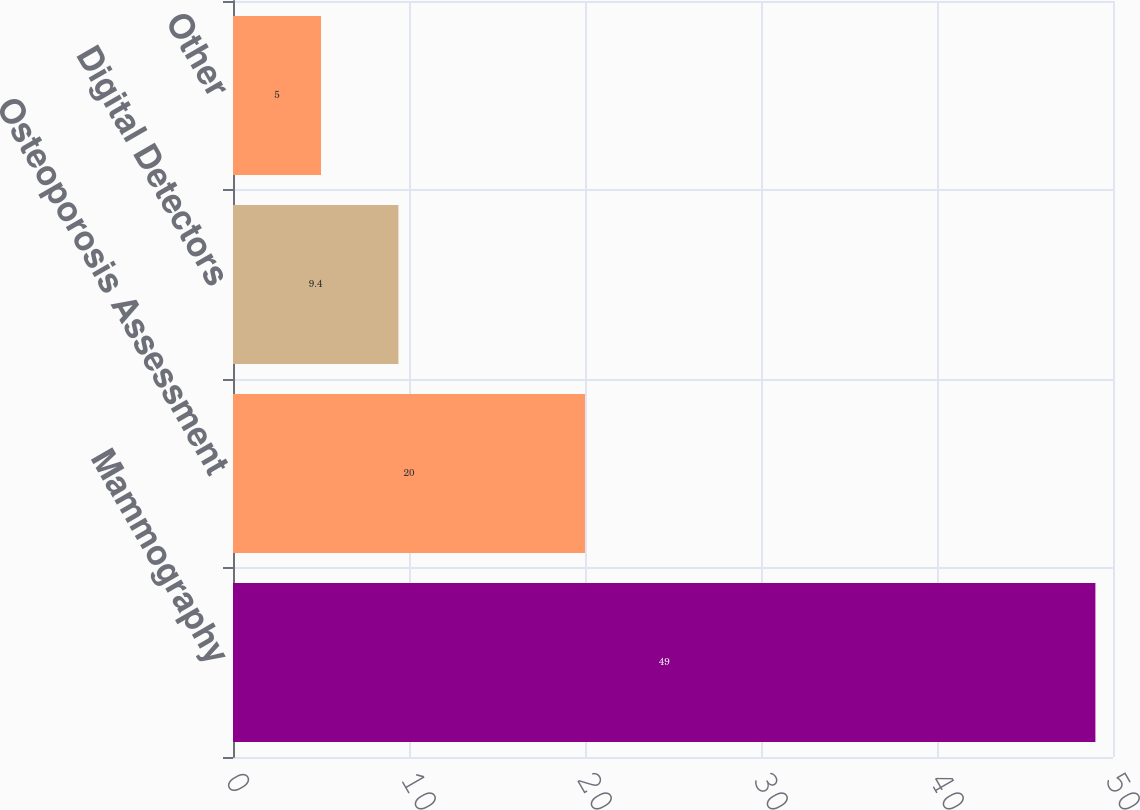Convert chart. <chart><loc_0><loc_0><loc_500><loc_500><bar_chart><fcel>Mammography<fcel>Osteoporosis Assessment<fcel>Digital Detectors<fcel>Other<nl><fcel>49<fcel>20<fcel>9.4<fcel>5<nl></chart> 